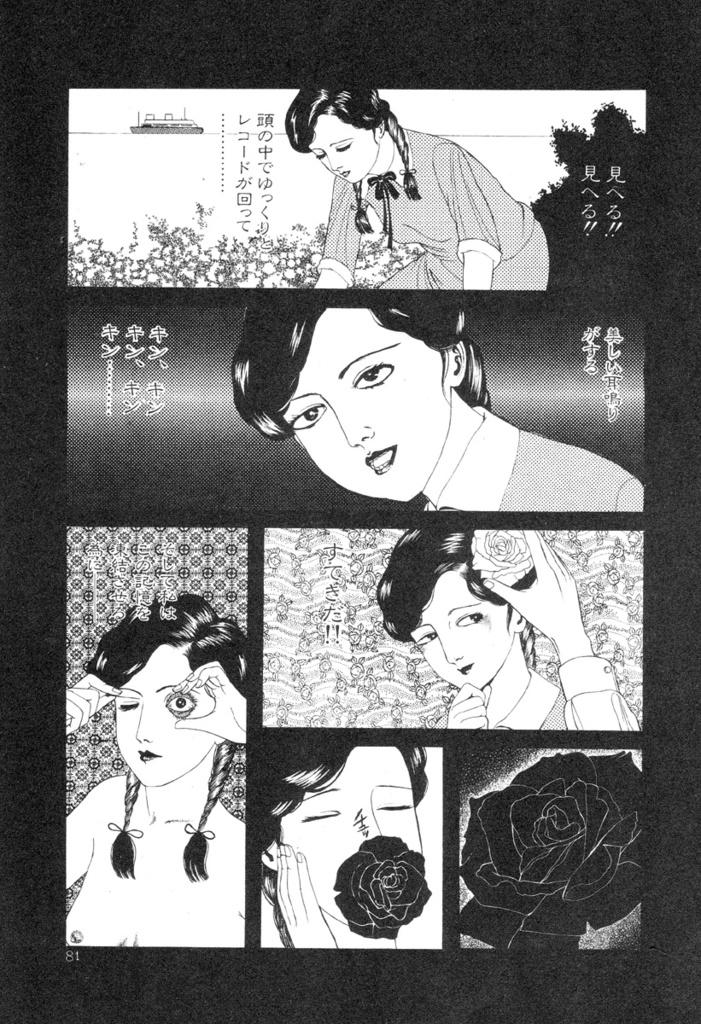What is present on the poster in the image? There is a poster in the image that contains images of persons and flowers. Can you describe the content of the poster in more detail? The poster contains images of persons and flowers, which suggests it might be related to a theme or event involving people and nature. What type of whistle can be heard in the image? There is no whistle present in the image, as it is a poster with images of persons and flowers. 